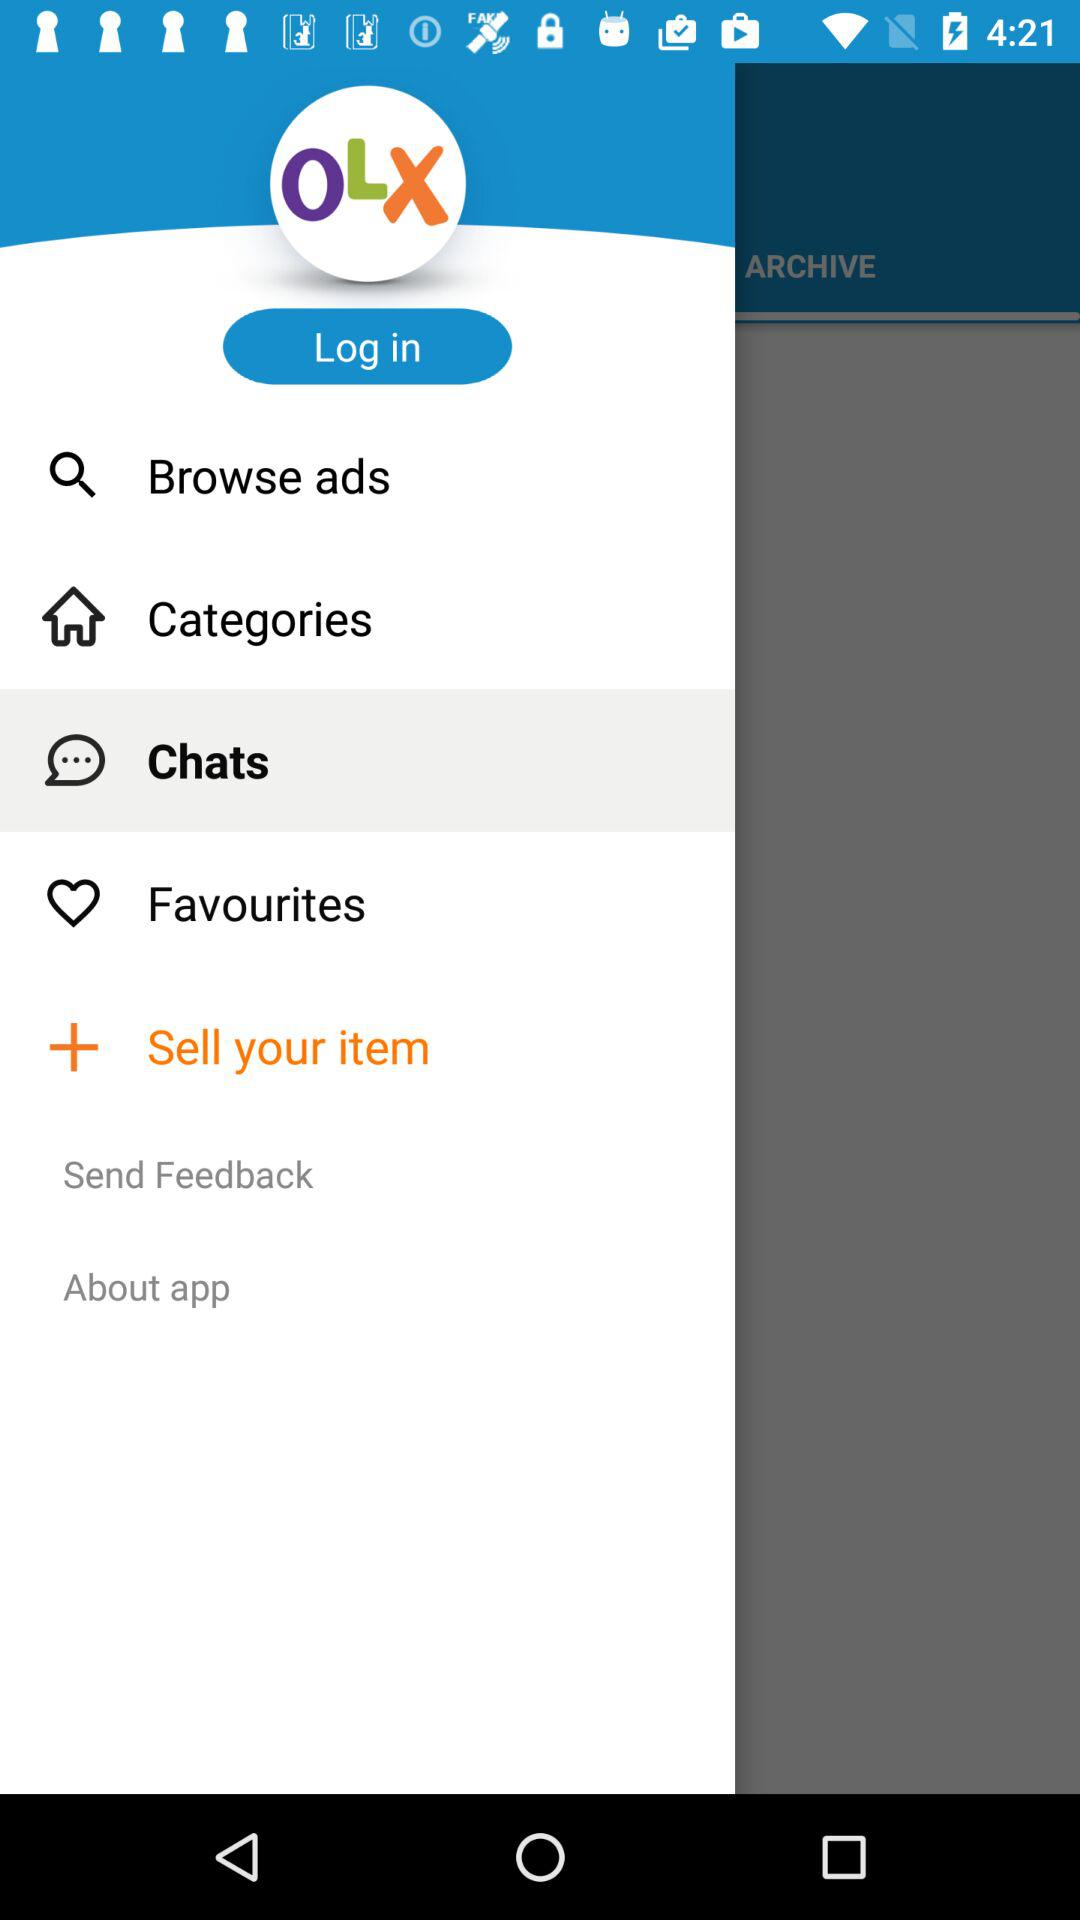What is the name of the application? The name of the application is "OLX". 